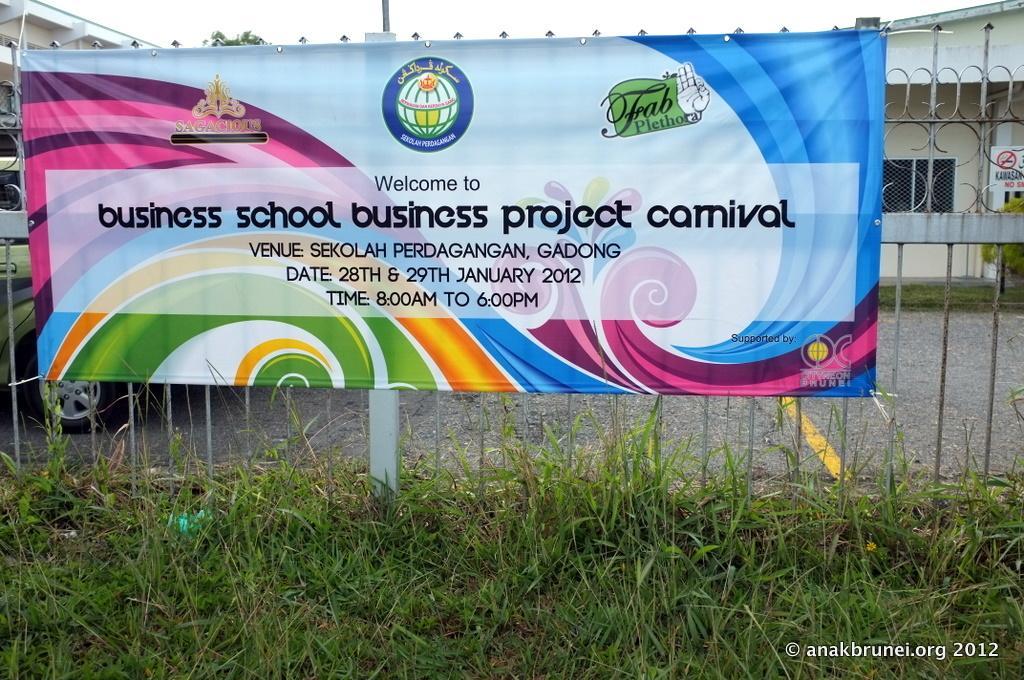Please provide a concise description of this image. In this image we can see there is a poster with some text on the fence, in front of it there is grass and behind it there are buildings, a signboard and a vehicle, in the background we can see the sky. 